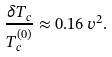Convert formula to latex. <formula><loc_0><loc_0><loc_500><loc_500>\frac { \delta T _ { c } } { T _ { c } ^ { ( 0 ) } } \approx 0 . 1 6 \, v ^ { 2 } .</formula> 